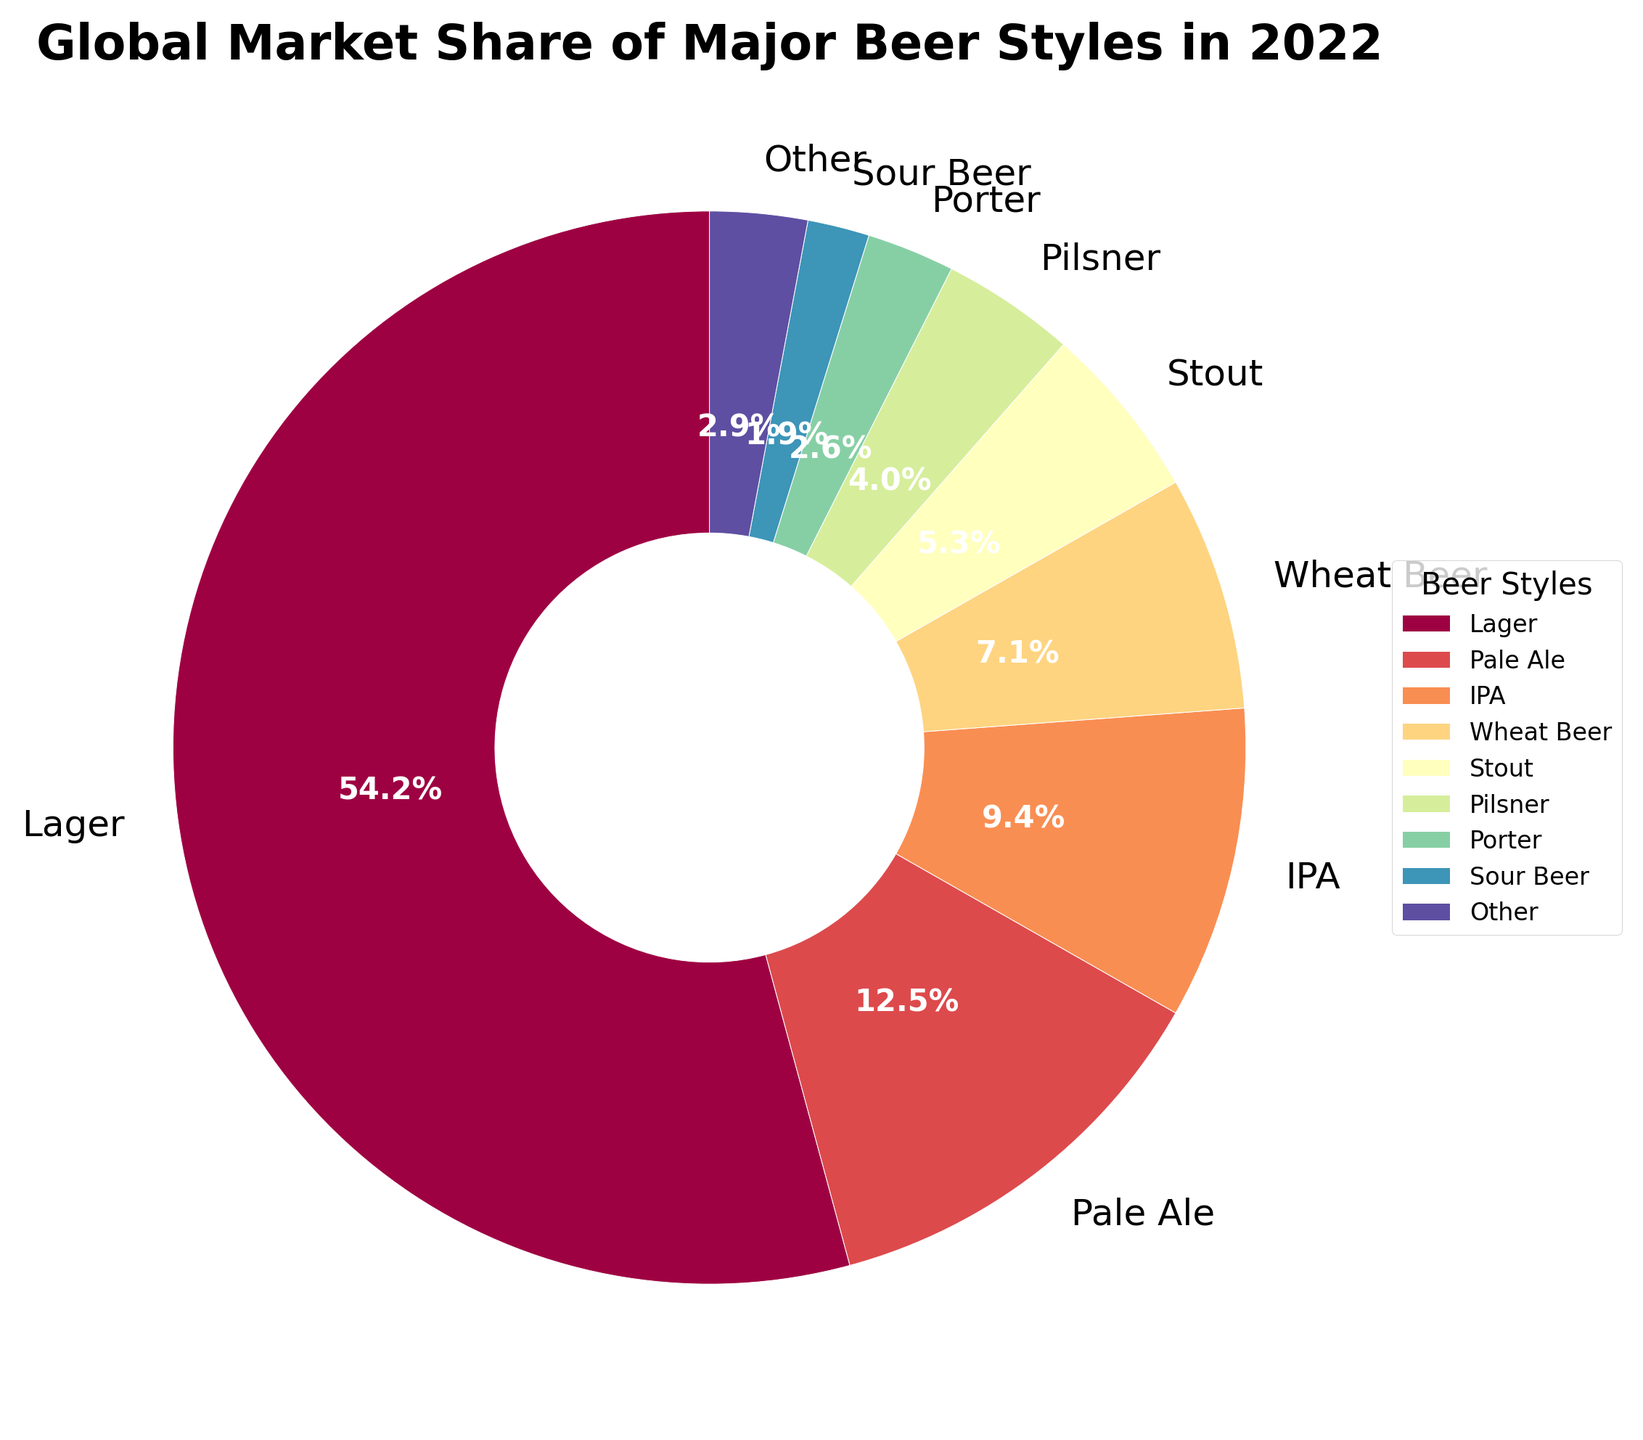What is the combined market share of Lager and IPA? First, find the market shares of Lager and IPA on the pie chart. Lager is 55.3% and IPA is 9.6%. Add them together: 55.3 + 9.6 = 64.9.
Answer: 64.9% Which beer style has the second highest market share and what is its value? Look at the sorted pie chart to identify the beer style with the second largest slice. The second largest slice belongs to Pale Ale with a market share of 12.8%.
Answer: Pale Ale, 12.8% Is the market share of Wheat Beer greater than the combined market share of Porter and Sour Beer? Find the market shares of Wheat Beer (7.2%), Porter (2.7%), and Sour Beer (1.9%). Add the shares of Porter and Sour Beer: 2.7 + 1.9 = 4.6. Compare them: 7.2 > 4.6.
Answer: Yes What is the difference in market share between Stout and Pilsner? Find the market shares of Stout (5.4%) and Pilsner (4.1%). Subtract the smaller share from the larger: 5.4 - 4.1 = 1.3.
Answer: 1.3% Which color corresponds to the 'Other' category and why is this category grouped separately? The 'Other' category wedge can be identified visually by its location in the legend and its color on the pie chart. It often appears in a distinctly different location from other specific beer styles in the chart. This category is grouped separately because it includes all data points beyond the top 8 beer styles to simplify the chart visualization.
Answer: The 'Other' category corresponds to the color shown in the legend; it is grouped separately to simplify the chart What is the sum of market shares of all beer styles excluding 'Other'? Identify market shares of the top 8 beer styles from the chart: Lager (55.3%), Pale Ale (12.8%), IPA (9.6%), Wheat Beer (7.2%), Stout (5.4%), Pilsner (4.1%), Porter (2.7%), Sour Beer (1.9%). Add these values: 55.3 + 12.8 + 9.6 + 7.2 + 5.4 + 4.1 + 2.7 + 1.9 = 99.
Answer: 99% How does the market share of Amber Ale compare to that of Belgian Ale? Identify the market shares of Amber Ale (0.9%) and Belgian Ale (1.5%) on the pie chart. Compare the values: 1.5% (Belgian Ale) is greater than 0.9% (Amber Ale).
Answer: Belgian Ale has a higher market share than Amber Ale What is the average market share of the top 4 beer styles? Identify the market shares of the top 4 beer styles: Lager (55.3%), Pale Ale (12.8%), IPA (9.6%), Wheat Beer (7.2%). Add these values and then divide by 4: (55.3 + 12.8 + 9.6 + 7.2) / 4 = 84.9 / 4 = 21.225.
Answer: 21.225% 